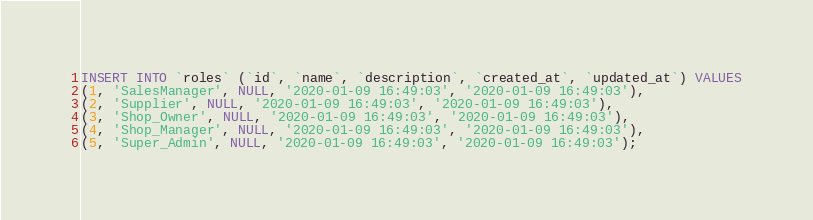Convert code to text. <code><loc_0><loc_0><loc_500><loc_500><_SQL_>
INSERT INTO `roles` (`id`, `name`, `description`, `created_at`, `updated_at`) VALUES
(1, 'SalesManager', NULL, '2020-01-09 16:49:03', '2020-01-09 16:49:03'),
(2, 'Supplier', NULL, '2020-01-09 16:49:03', '2020-01-09 16:49:03'),
(3, 'Shop_Owner', NULL, '2020-01-09 16:49:03', '2020-01-09 16:49:03'),
(4, 'Shop_Manager', NULL, '2020-01-09 16:49:03', '2020-01-09 16:49:03'),
(5, 'Super_Admin', NULL, '2020-01-09 16:49:03', '2020-01-09 16:49:03');</code> 